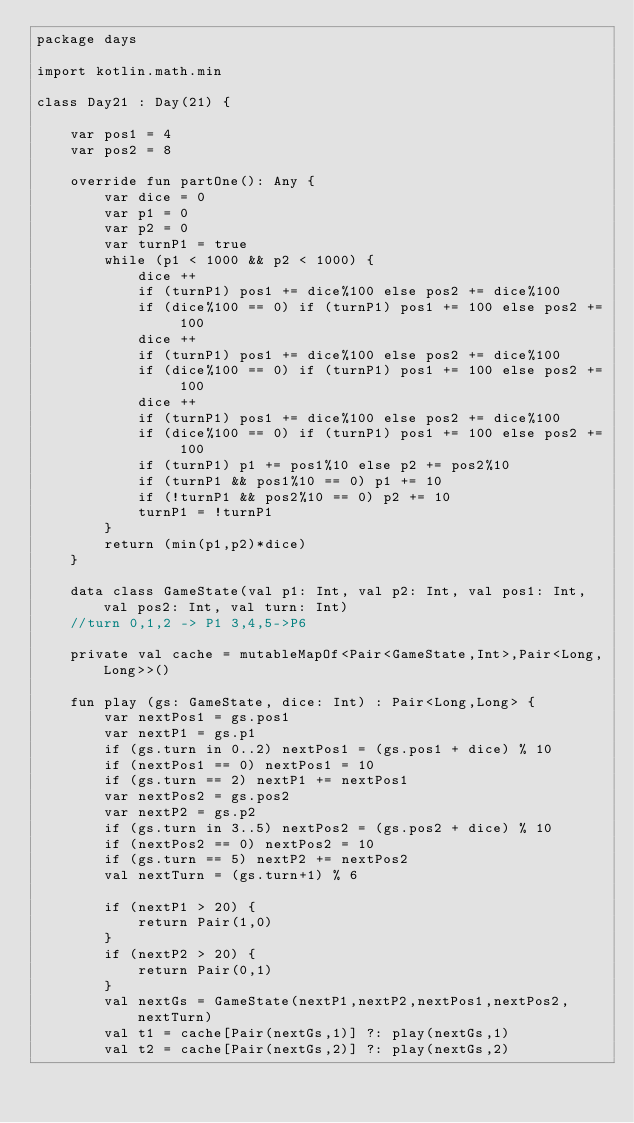<code> <loc_0><loc_0><loc_500><loc_500><_Kotlin_>package days

import kotlin.math.min

class Day21 : Day(21) {

    var pos1 = 4
    var pos2 = 8

    override fun partOne(): Any {
        var dice = 0
        var p1 = 0
        var p2 = 0
        var turnP1 = true
        while (p1 < 1000 && p2 < 1000) {
            dice ++
            if (turnP1) pos1 += dice%100 else pos2 += dice%100
            if (dice%100 == 0) if (turnP1) pos1 += 100 else pos2 += 100
            dice ++
            if (turnP1) pos1 += dice%100 else pos2 += dice%100
            if (dice%100 == 0) if (turnP1) pos1 += 100 else pos2 += 100
            dice ++
            if (turnP1) pos1 += dice%100 else pos2 += dice%100
            if (dice%100 == 0) if (turnP1) pos1 += 100 else pos2 += 100
            if (turnP1) p1 += pos1%10 else p2 += pos2%10
            if (turnP1 && pos1%10 == 0) p1 += 10
            if (!turnP1 && pos2%10 == 0) p2 += 10
            turnP1 = !turnP1
        }
        return (min(p1,p2)*dice)
    }

    data class GameState(val p1: Int, val p2: Int, val pos1: Int, val pos2: Int, val turn: Int)
    //turn 0,1,2 -> P1 3,4,5->P6

    private val cache = mutableMapOf<Pair<GameState,Int>,Pair<Long,Long>>()

    fun play (gs: GameState, dice: Int) : Pair<Long,Long> {
        var nextPos1 = gs.pos1
        var nextP1 = gs.p1
        if (gs.turn in 0..2) nextPos1 = (gs.pos1 + dice) % 10
        if (nextPos1 == 0) nextPos1 = 10
        if (gs.turn == 2) nextP1 += nextPos1
        var nextPos2 = gs.pos2
        var nextP2 = gs.p2
        if (gs.turn in 3..5) nextPos2 = (gs.pos2 + dice) % 10
        if (nextPos2 == 0) nextPos2 = 10
        if (gs.turn == 5) nextP2 += nextPos2
        val nextTurn = (gs.turn+1) % 6

        if (nextP1 > 20) {
            return Pair(1,0)
        }
        if (nextP2 > 20) {
            return Pair(0,1)
        }
        val nextGs = GameState(nextP1,nextP2,nextPos1,nextPos2,nextTurn)
        val t1 = cache[Pair(nextGs,1)] ?: play(nextGs,1)
        val t2 = cache[Pair(nextGs,2)] ?: play(nextGs,2)</code> 